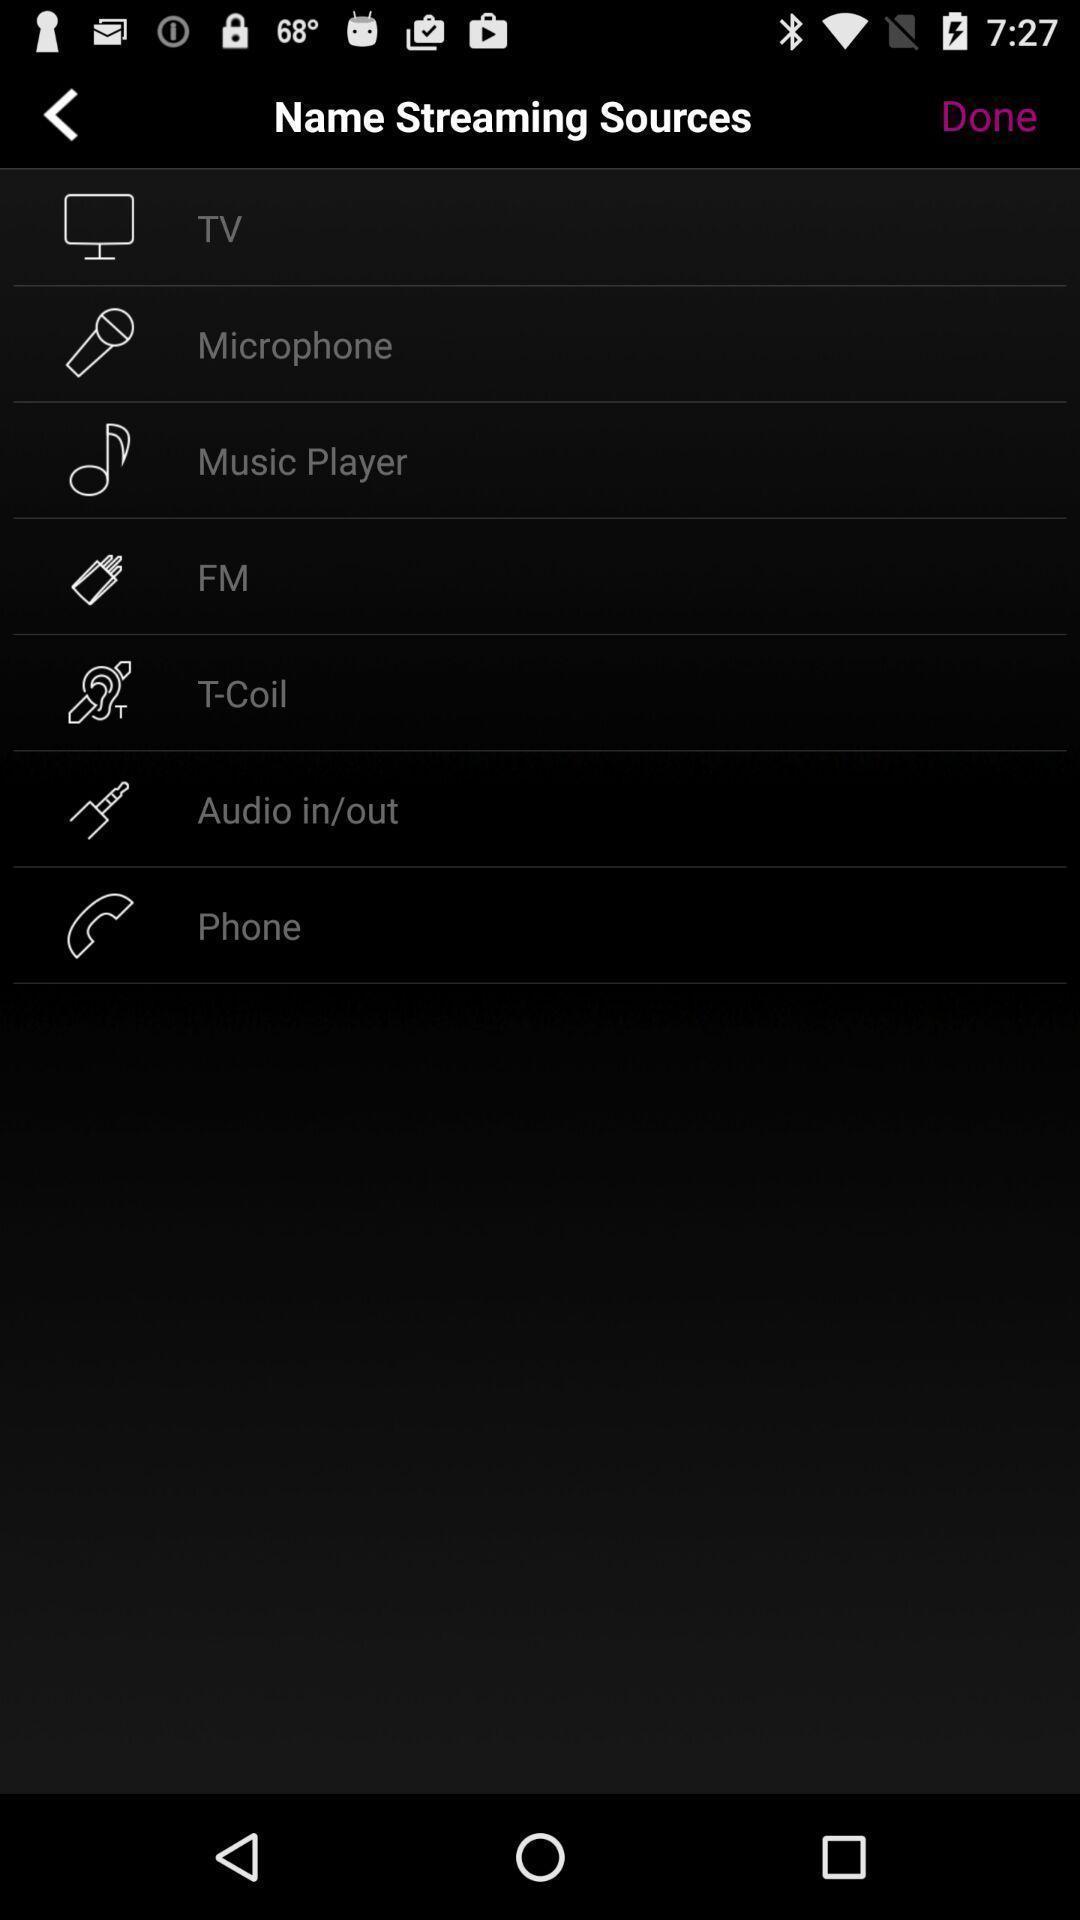Give me a narrative description of this picture. Screen display various options. 